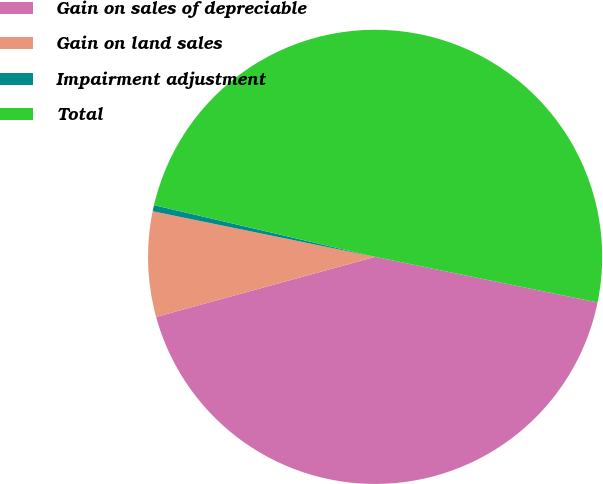Convert chart to OTSL. <chart><loc_0><loc_0><loc_500><loc_500><pie_chart><fcel>Gain on sales of depreciable<fcel>Gain on land sales<fcel>Impairment adjustment<fcel>Total<nl><fcel>42.52%<fcel>7.48%<fcel>0.44%<fcel>49.56%<nl></chart> 